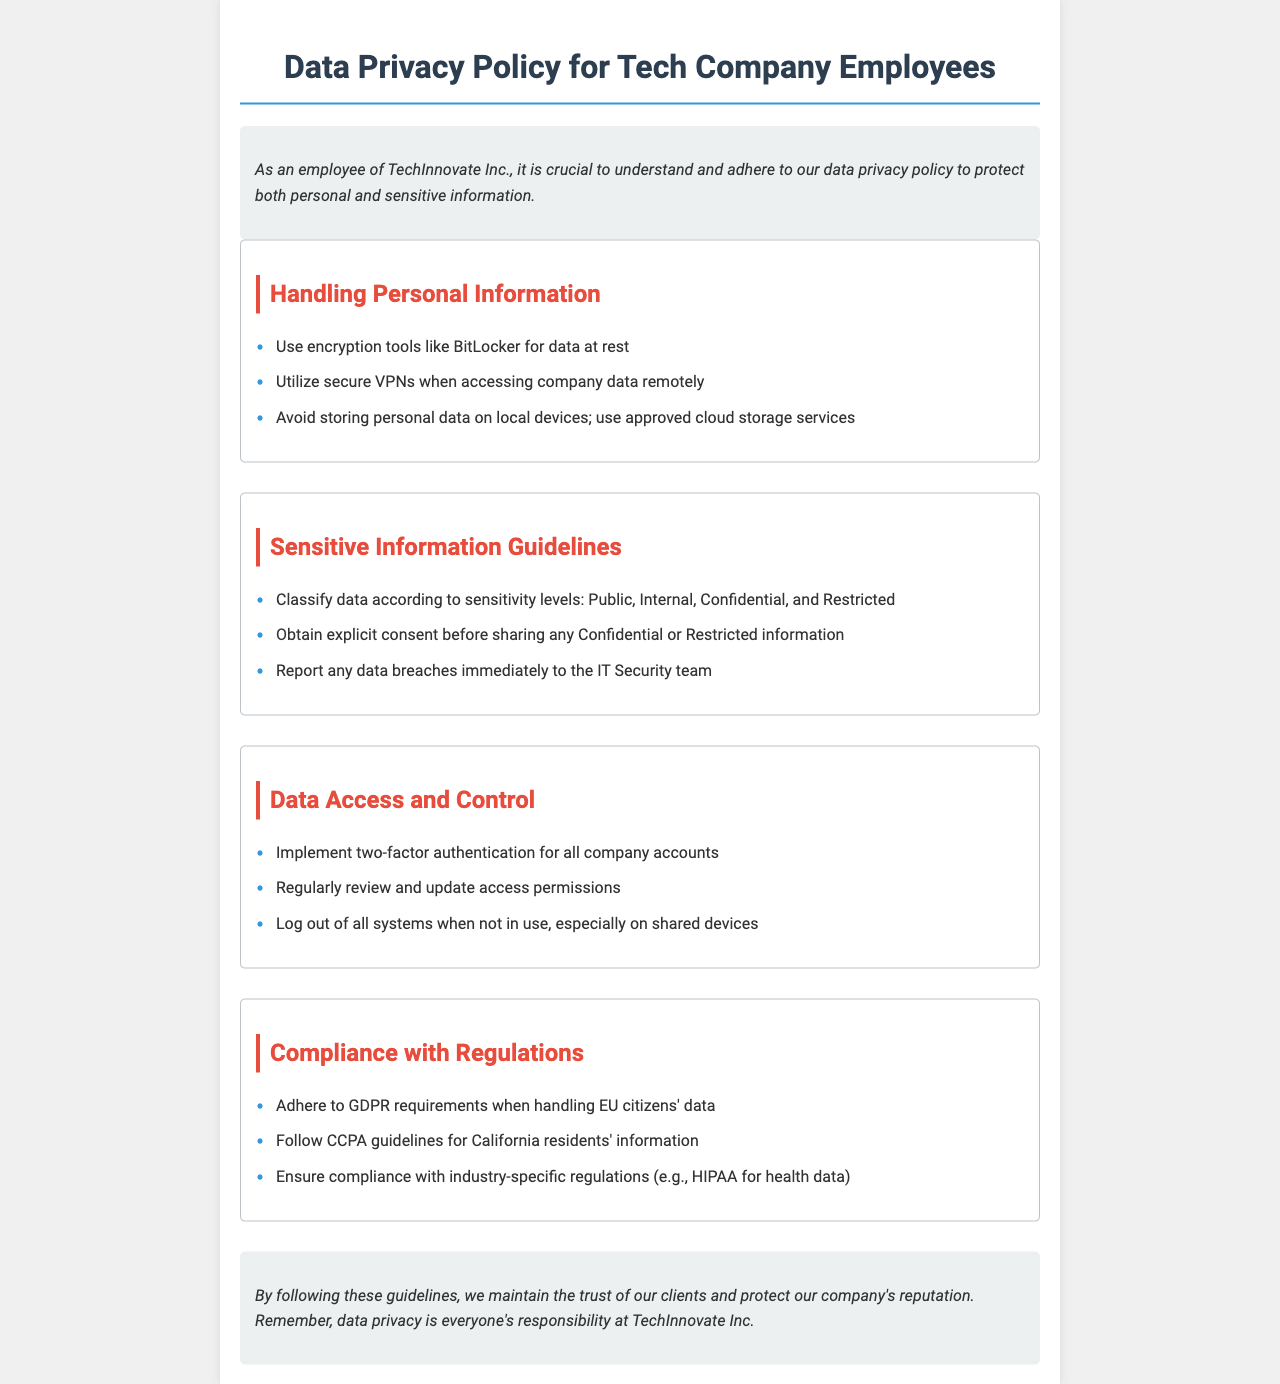What is the purpose of this document? The document outlines guidelines for employees regarding the handling of personal and sensitive information to protect data privacy.
Answer: Protect data privacy What tool should be used for data at rest? The document specifies the use of encryption tools for data at rest.
Answer: BitLocker Which team should data breaches be reported to? The policy states that data breaches should be reported to a specific team.
Answer: IT Security team What levels of data sensitivity are mentioned? The guideline section discusses the classification of data according to specific sensitivity levels.
Answer: Public, Internal, Confidential, Restricted What is required before sharing Confidential information? The document outlines a specific requirement before sharing certain types of information.
Answer: Explicit consent What authentication method is recommended for company accounts? The policy describes a security measure to protect company accounts.
Answer: Two-factor authentication Which regulations must be adhered to for handling EU citizens' data? The document specifies a regulation that governs the handling of EU citizens' data.
Answer: GDPR How often should access permissions be reviewed? The guidelines suggest a routine action for maintaining security regarding access permissions.
Answer: Regularly What is the responsibility of employees regarding data privacy? The conclusion states the expectation for employees regarding data privacy.
Answer: Everyone's responsibility 